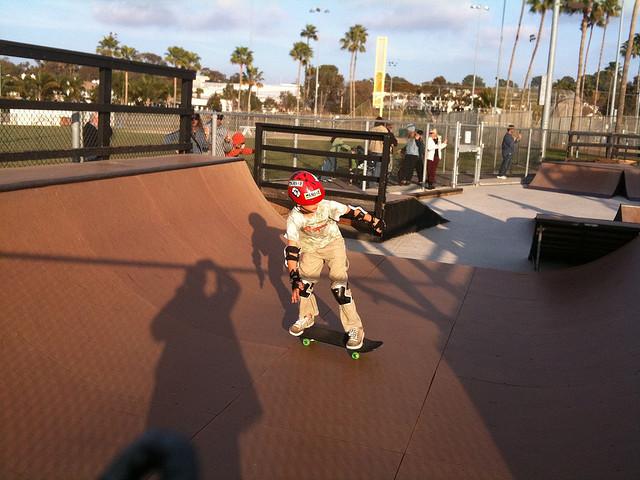What gear is the child using for safety?
Keep it brief. Helmet. Could a parent be taking a photo?
Concise answer only. Yes. Is that a Half Pipe?
Answer briefly. Yes. 